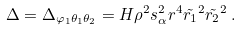<formula> <loc_0><loc_0><loc_500><loc_500>\Delta = \Delta _ { \varphi _ { 1 } \theta _ { 1 } \theta _ { 2 } } = H \rho ^ { 2 } s _ { \alpha } ^ { 2 } r ^ { 4 } \tilde { r _ { 1 } } ^ { 2 } \tilde { r _ { 2 } } ^ { 2 } \, .</formula> 